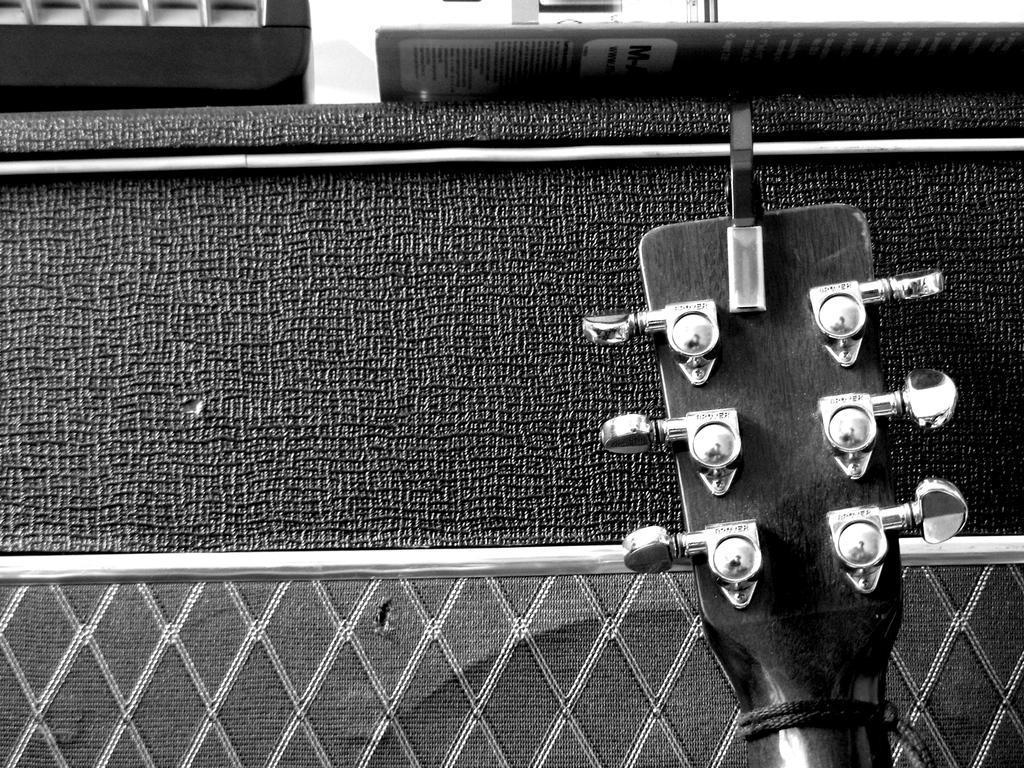Describe this image in one or two sentences. This is a black and white picture and there is a guitar head in this picture 